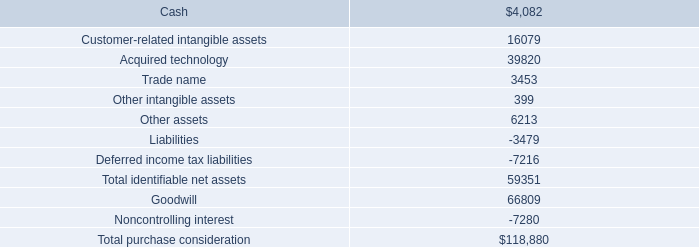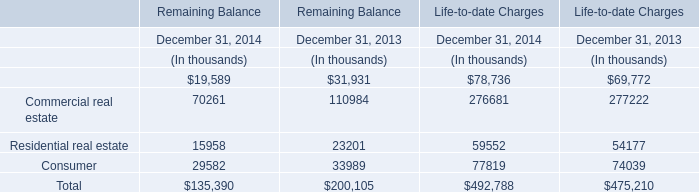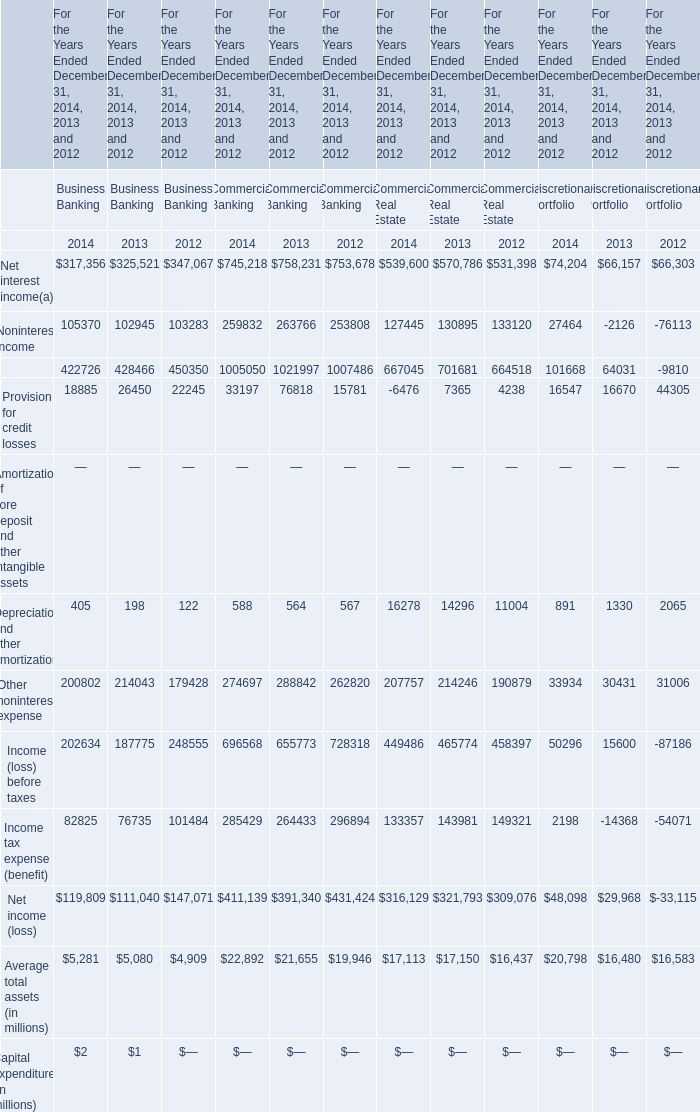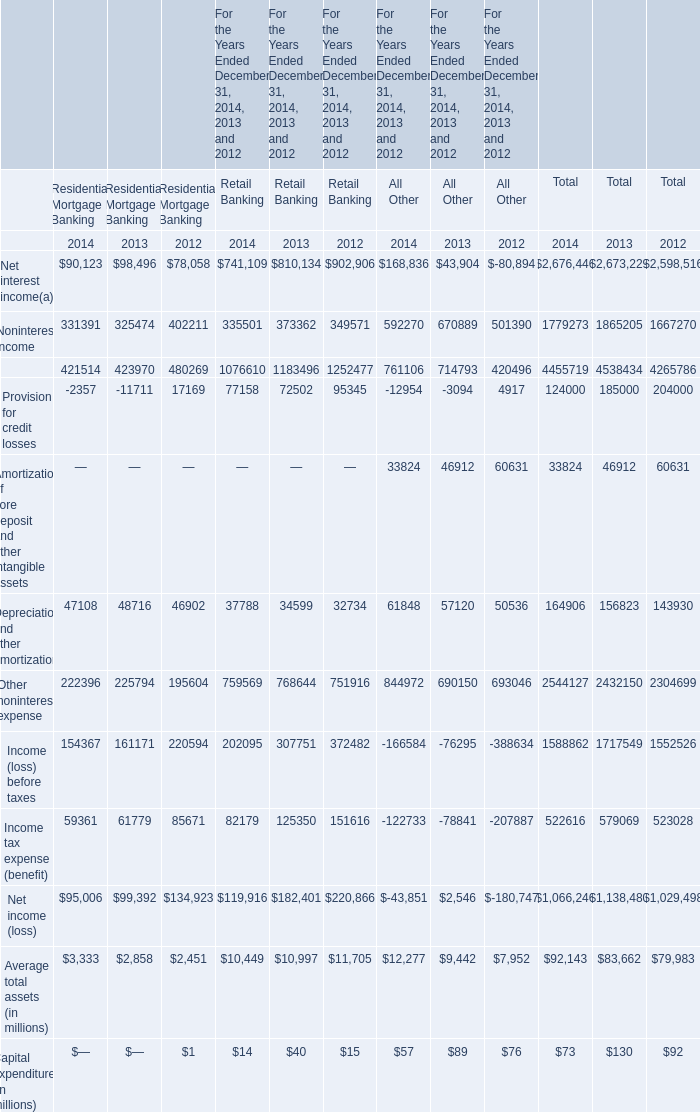What is the ratio of Depreciation and other amortization to the total in 2014 for Residential Mortgage Banking? 
Computations: (47108 / (((((((421514 - 2357) + 47108) + 222396) + 154367) + 59361) + 3333) + 95006))
Answer: 0.04707. 